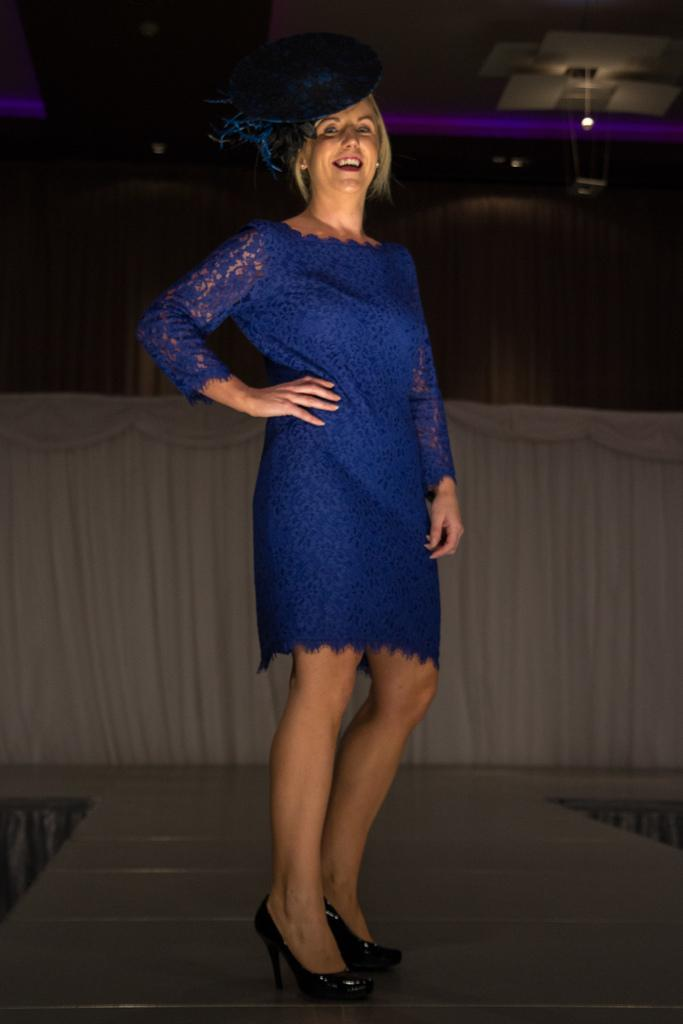Who is present in the image? There is a woman in the image. What is the woman doing in the image? The woman is standing and smiling. What can be seen in the background of the image? There is a curtain visible in the background of the image. How would you describe the lighting in the image? The background of the image is dark. What arithmetic problem is the woman solving in the image? There is no arithmetic problem visible in the image. How many children are present in the image? There are no children present in the image; only the woman is visible. 